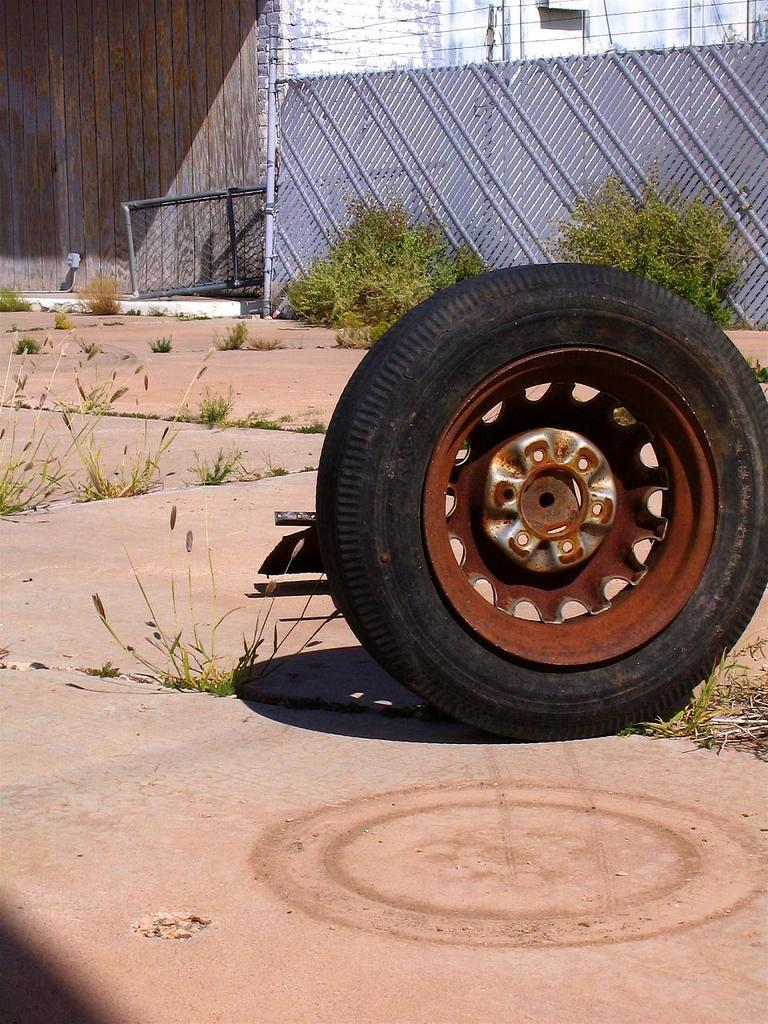What object is the main focus of the image? There is a tire in the image. What else can be seen on the ground in the image? There are plants on the ground in the image. What is visible in the background of the image? There is a wall in the background of the image. What material is the wall made of? There is a wooden wall in the image. Can you tell me how many heads of lettuce are growing in the image? There is no lettuce present in the image; it features a tire, plants, and a wooden wall. What type of ocean can be seen in the image? There is no ocean present in the image. 